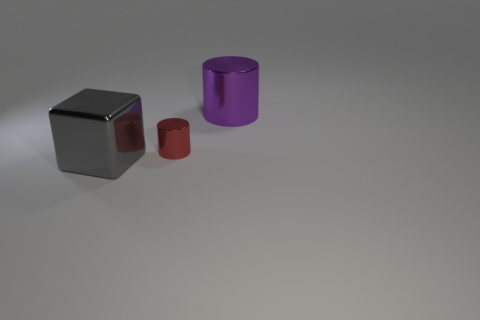Is there anything else that has the same size as the red cylinder?
Offer a terse response. No. Is the size of the purple metallic cylinder the same as the metallic cube?
Offer a very short reply. Yes. What is the color of the other metallic object that is the same shape as the small red metal object?
Your answer should be very brief. Purple. Is the number of big metal things behind the tiny cylinder greater than the number of large gray cubes?
Keep it short and to the point. No. What is the color of the metal cylinder that is in front of the big metal thing behind the large gray thing?
Make the answer very short. Red. What number of objects are either big purple cylinders behind the big metal block or large metallic things to the right of the big metal cube?
Give a very brief answer. 1. What is the color of the small metal object?
Keep it short and to the point. Red. How many big gray blocks have the same material as the tiny cylinder?
Keep it short and to the point. 1. Is the number of purple objects greater than the number of small red shiny balls?
Make the answer very short. Yes. There is a big object in front of the large purple shiny thing; how many gray blocks are behind it?
Keep it short and to the point. 0. 